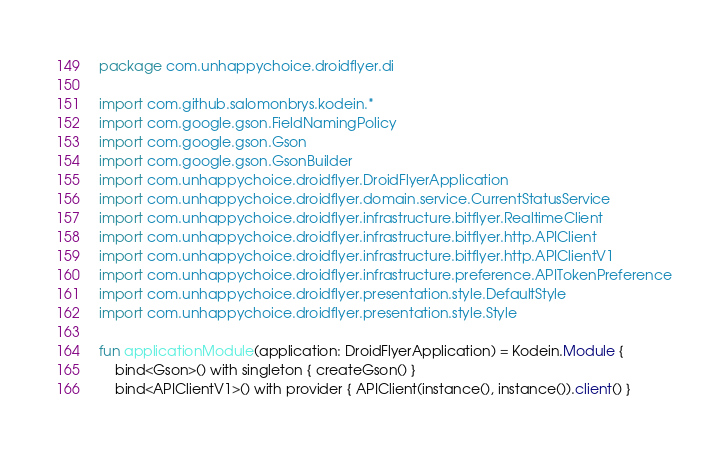<code> <loc_0><loc_0><loc_500><loc_500><_Kotlin_>package com.unhappychoice.droidflyer.di

import com.github.salomonbrys.kodein.*
import com.google.gson.FieldNamingPolicy
import com.google.gson.Gson
import com.google.gson.GsonBuilder
import com.unhappychoice.droidflyer.DroidFlyerApplication
import com.unhappychoice.droidflyer.domain.service.CurrentStatusService
import com.unhappychoice.droidflyer.infrastructure.bitflyer.RealtimeClient
import com.unhappychoice.droidflyer.infrastructure.bitflyer.http.APIClient
import com.unhappychoice.droidflyer.infrastructure.bitflyer.http.APIClientV1
import com.unhappychoice.droidflyer.infrastructure.preference.APITokenPreference
import com.unhappychoice.droidflyer.presentation.style.DefaultStyle
import com.unhappychoice.droidflyer.presentation.style.Style

fun applicationModule(application: DroidFlyerApplication) = Kodein.Module {
    bind<Gson>() with singleton { createGson() }
    bind<APIClientV1>() with provider { APIClient(instance(), instance()).client() }</code> 